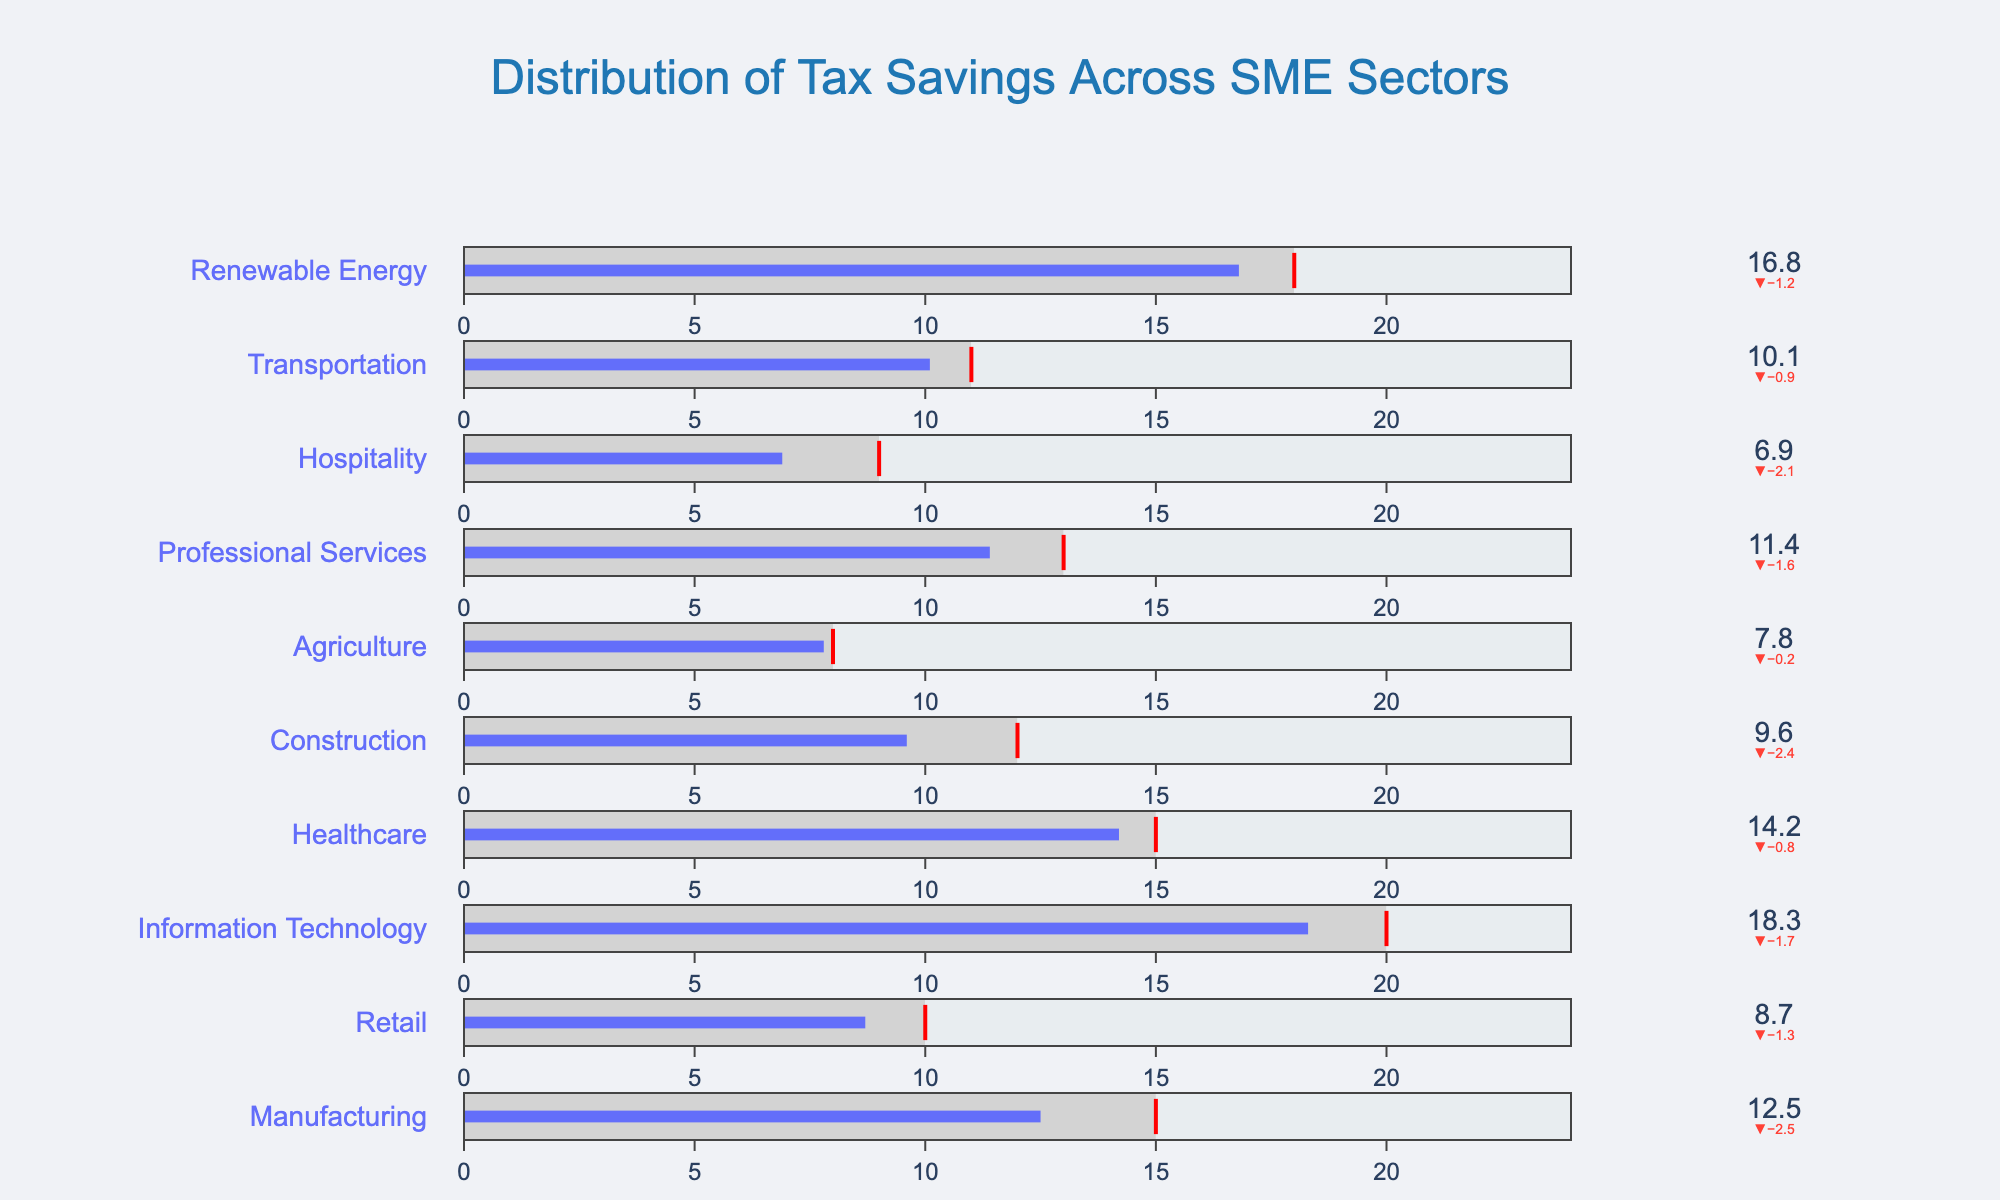What is the title of the figure? The title of the figure is presented at the top of the chart and typically provides an overview of what the figure represents.
Answer: Distribution of Tax Savings Across SME Sectors Which sector has the highest actual tax savings percentage? Summarize the value bars for each sector to identify the one with the highest actual tax savings percentage.
Answer: Information Technology What are the actual and target tax savings percentages for the Retail sector? Locate the Retail sector in the chart and read the values for actual and target tax savings percentages.
Answer: Actual: 8.7%, Target: 10% How much difference is there between actual and target tax savings in the Healthcare sector? Find the difference between actual (14.2%) and target (15%) tax savings in the Healthcare sector.
Answer: 0.8% For which sector is the actual tax savings percentage below the target value? Compare each sector's actual tax savings percentage to its target to identify those falling short.
Answer: Retail, Construction, Agriculture, Professional Services, Hospitality, Transportation Which sector comes closest to meeting its target tax savings percentage without exceeding it? Determine the sector in which the actual tax savings percentage is closest to but not greater than the target percentage by comparing the gaps.
Answer: Agriculture How many sectors exceeded their target tax savings percentages? Count the number of sectors where the actual tax savings percentage is higher than the target percentage.
Answer: 4 What is the average target tax savings percentage across all sectors? Sum all target tax savings percentages and divide by the number of sectors to calculate the average. (15 + 10 + 20 + 15 + 12 + 8 + 13 + 9 + 11 + 18) / 10
Answer: 13.1% Which sector has its actual tax savings percentage closest to the target without exceeding it? Compare the difference between actual and target savings for each sector, then identify the smallest positive difference or closest to zero without negative.
Answer: Agriculture What color represents the actual tax savings percentage in the bullet chart? Identify the color used in the bullet bars representing actual tax savings across sectors.
Answer: Blue 